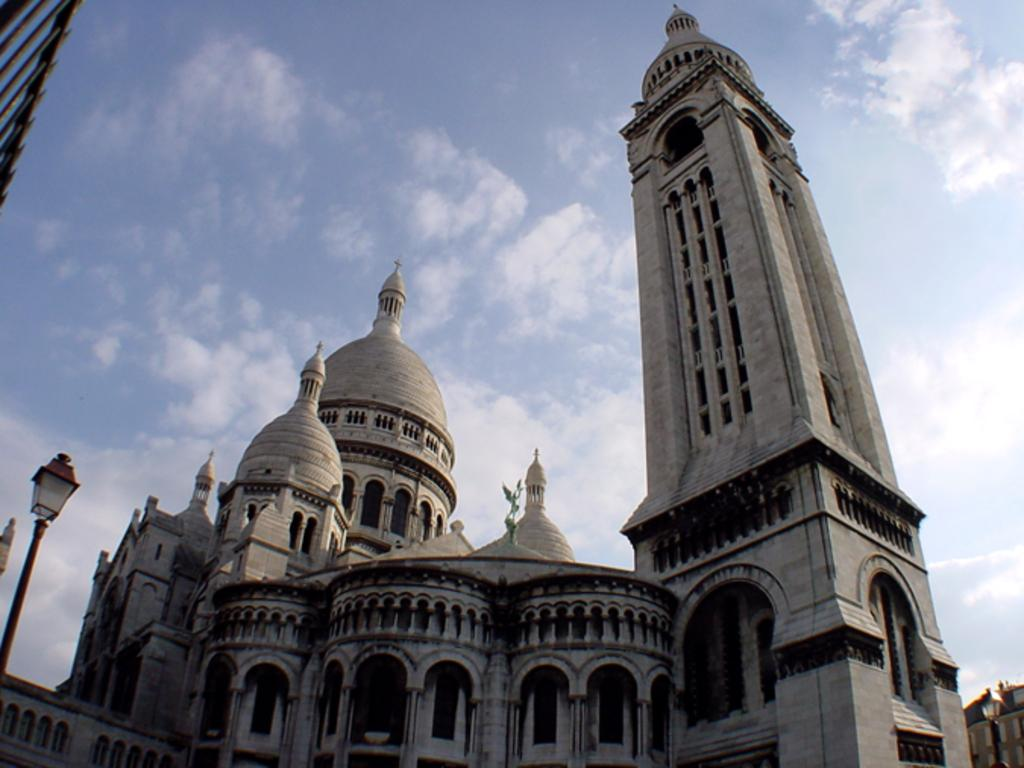What type of structures are visible in the image? There are tomb buildings in the image. What else can be seen in the image besides the tomb buildings? There is a street light pole in the image. How would you describe the sky in the image? The sky is cloudy in the image. Can you tell me how many balls are rolling down the drain in the image? There are no balls or drains present in the image; it features tomb buildings and a street light pole. What type of flock is flying over the tomb buildings in the image? There is no flock of birds or any other animals visible in the image. 